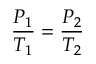<formula> <loc_0><loc_0><loc_500><loc_500>{ \frac { P _ { 1 } } { T _ { 1 } } } = { \frac { P _ { 2 } } { T _ { 2 } } }</formula> 